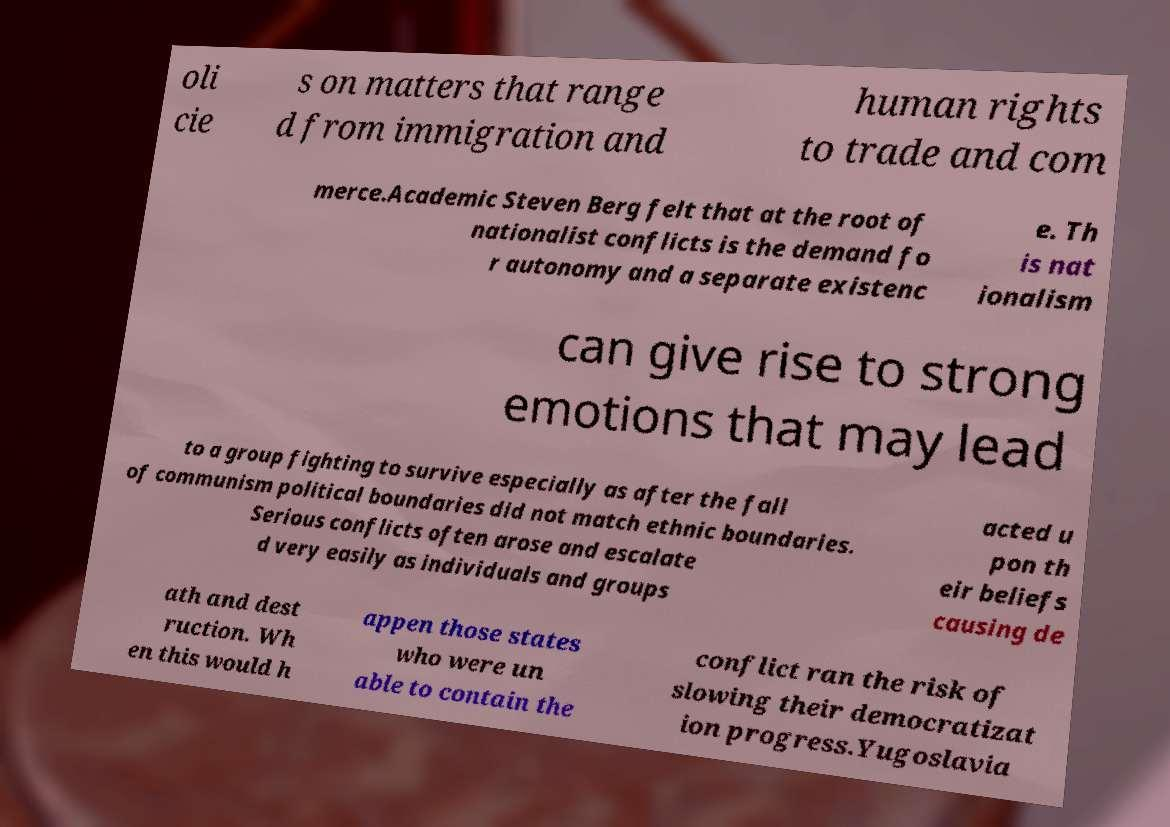Please identify and transcribe the text found in this image. oli cie s on matters that range d from immigration and human rights to trade and com merce.Academic Steven Berg felt that at the root of nationalist conflicts is the demand fo r autonomy and a separate existenc e. Th is nat ionalism can give rise to strong emotions that may lead to a group fighting to survive especially as after the fall of communism political boundaries did not match ethnic boundaries. Serious conflicts often arose and escalate d very easily as individuals and groups acted u pon th eir beliefs causing de ath and dest ruction. Wh en this would h appen those states who were un able to contain the conflict ran the risk of slowing their democratizat ion progress.Yugoslavia 